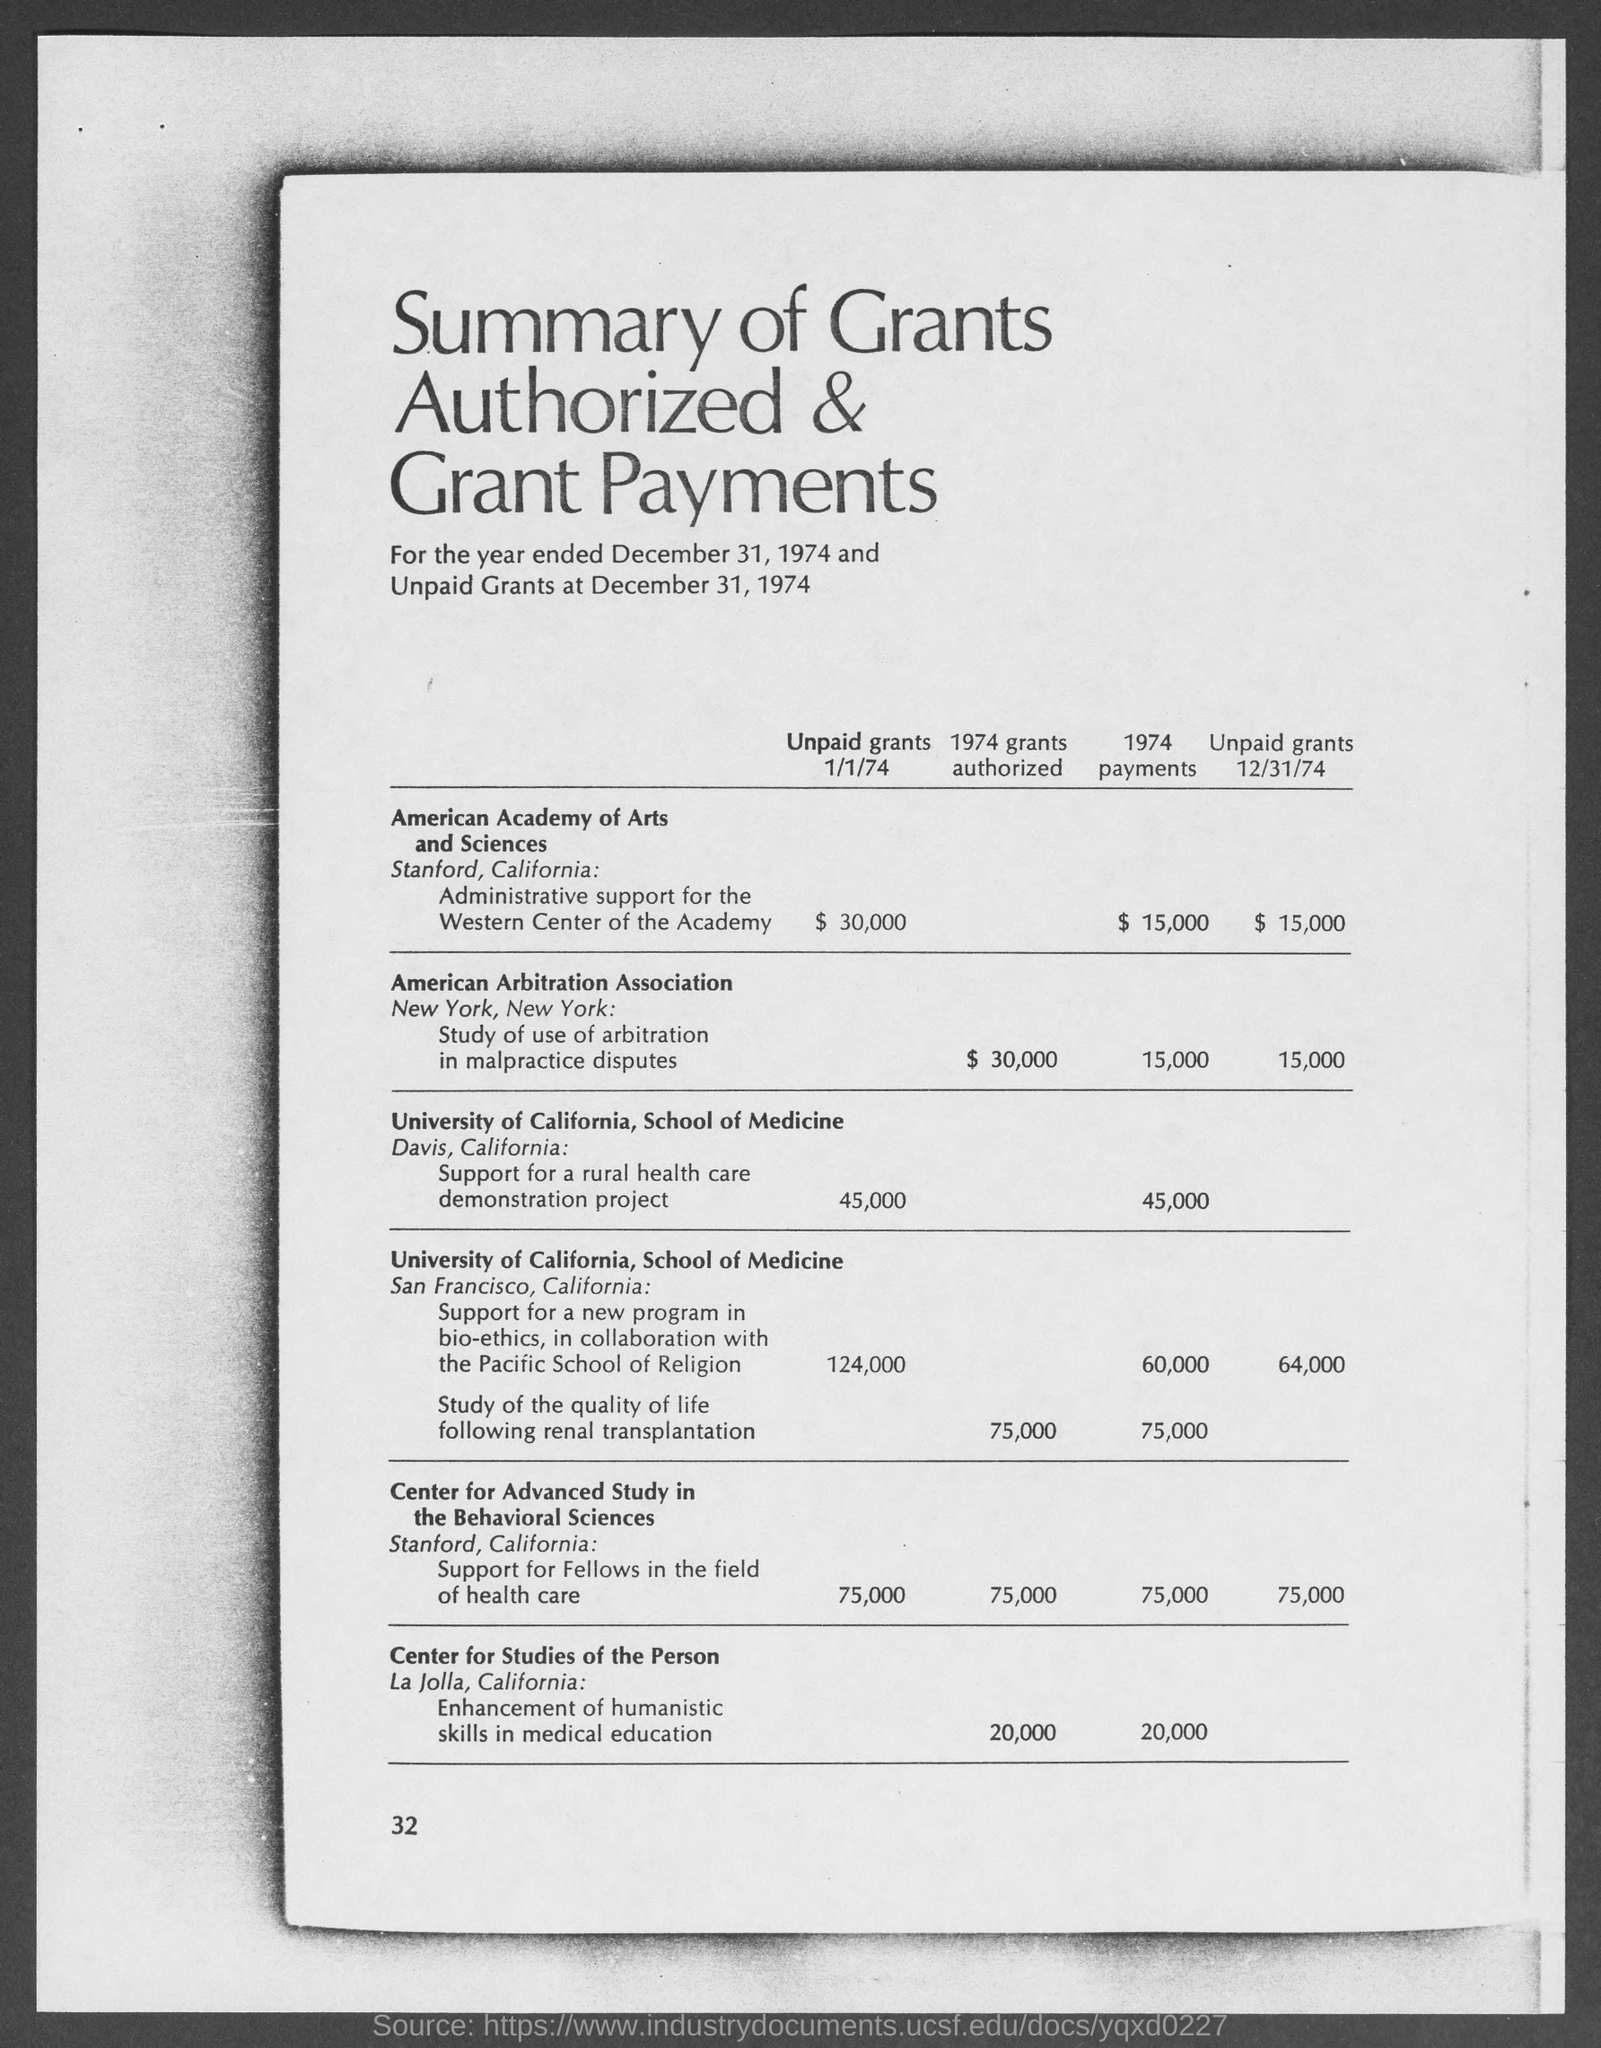Indicate a few pertinent items in this graphic. As of December 31, 1974, the unpaid grants of the American Arbitration Association were valued at $15,000. The speaker is asking for the page number to be provided as 32. 